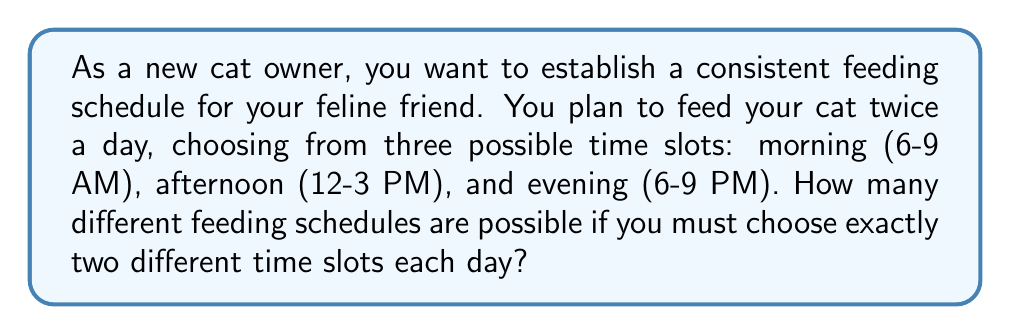Help me with this question. Let's approach this step-by-step:

1) We have three time slots to choose from: morning, afternoon, and evening.

2) We need to select two different time slots for feeding.

3) This is a combination problem, where the order of selection doesn't matter (e.g., choosing morning and evening is the same as choosing evening and morning).

4) The formula for combinations is:

   $$C(n,r) = \frac{n!}{r!(n-r)!}$$

   Where $n$ is the total number of items to choose from, and $r$ is the number of items being chosen.

5) In this case, $n = 3$ (three time slots) and $r = 2$ (we're choosing two slots).

6) Plugging these values into our formula:

   $$C(3,2) = \frac{3!}{2!(3-2)!} = \frac{3!}{2!(1)!}$$

7) Simplifying:
   
   $$\frac{3 * 2 * 1}{(2 * 1)(1)} = \frac{6}{2} = 3$$

Therefore, there are 3 possible feeding schedules:
1. Morning and Afternoon
2. Morning and Evening
3. Afternoon and Evening
Answer: 3 possible feeding schedules 